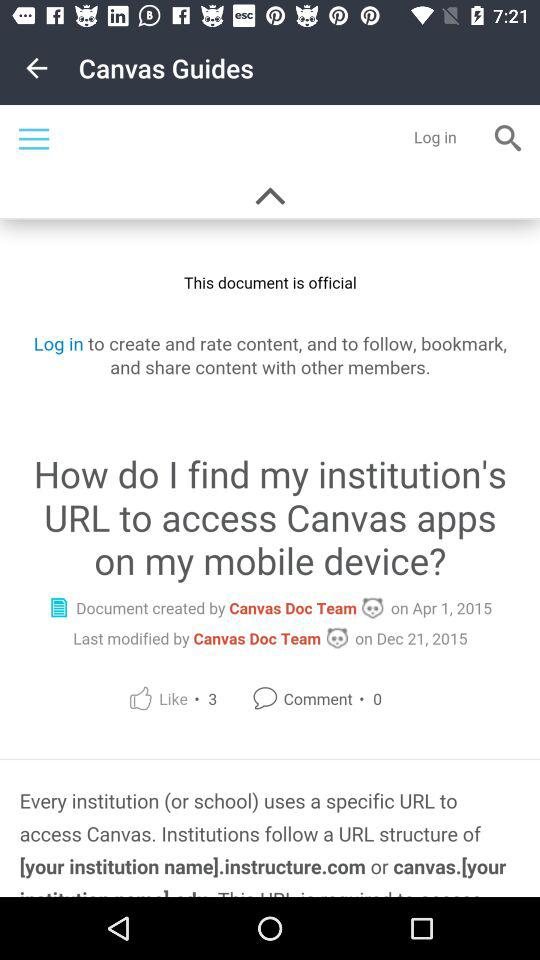How many likes did the document get? The document got 3 likes. 